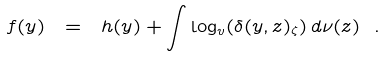Convert formula to latex. <formula><loc_0><loc_0><loc_500><loc_500>f ( y ) \ = \ h ( y ) + \int \log _ { v } ( \delta ( y , z ) _ { \zeta } ) \, d \nu ( z ) \ .</formula> 